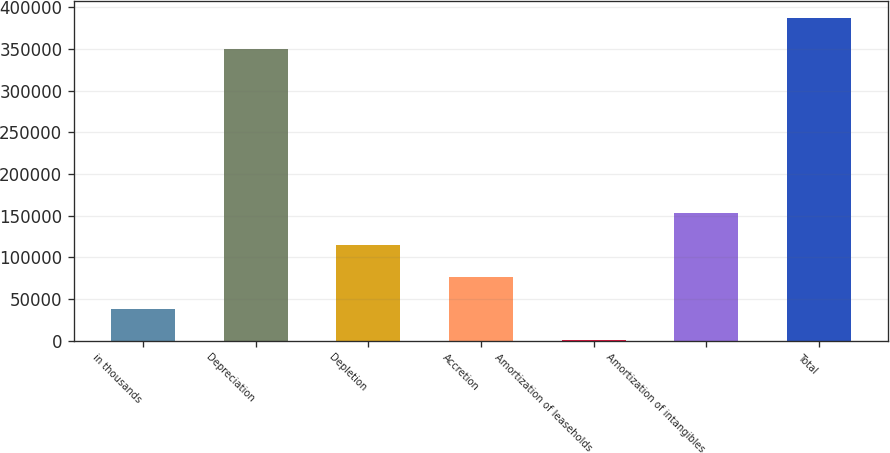<chart> <loc_0><loc_0><loc_500><loc_500><bar_chart><fcel>in thousands<fcel>Depreciation<fcel>Depletion<fcel>Accretion<fcel>Amortization of leaseholds<fcel>Amortization of intangibles<fcel>Total<nl><fcel>38384.8<fcel>349460<fcel>114764<fcel>76574.6<fcel>195<fcel>152954<fcel>387650<nl></chart> 